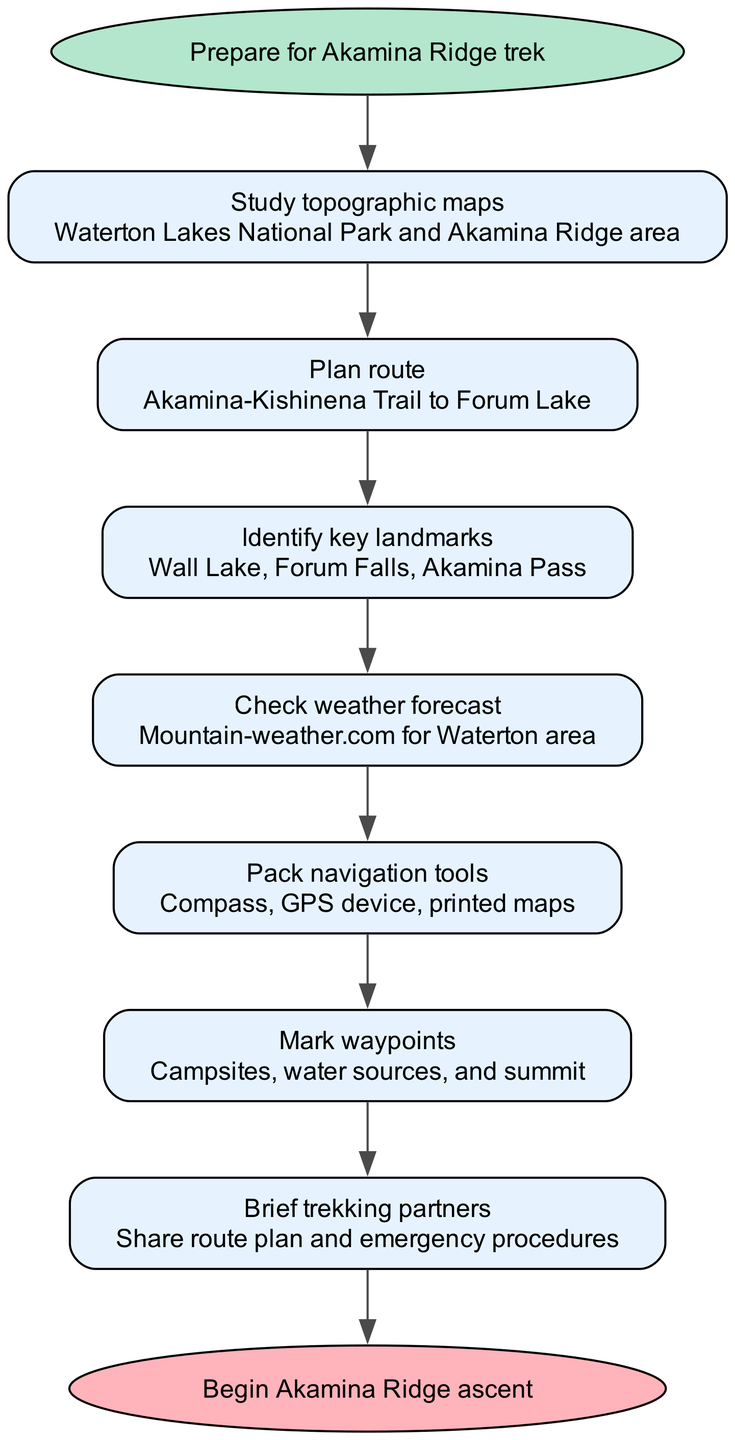What is the first step in the navigation process? The diagram indicates that the first step is "Study topographic maps" which is directly connected to the starting node.
Answer: Study topographic maps How many steps are included in the navigation and route-finding process? By counting each step node connected in the diagram, there are 7 steps outlined before reaching the end node.
Answer: 7 What is the last step before beginning the ascent? The last step listed in the sequence is "Brief trekking partners," which connects to the final node indicating the start of the ascent.
Answer: Brief trekking partners Which step involves checking the weather? The step that specifically mentions checking the weather is "Check weather forecast," which is part of the sequential steps leading to the ascent.
Answer: Check weather forecast What are the key landmarks identified in the process? The landmarks listed in the diagram are "Wall Lake, Forum Falls, Akamina Pass," which are part of the "Identify key landmarks" step.
Answer: Wall Lake, Forum Falls, Akamina Pass What is required to be packed according to the process? The process instructs to "Pack navigation tools" which includes compass, GPS device, and printed maps, detailed in that step.
Answer: Compass, GPS device, printed maps How does one transition from "Plan route" to "Identify key landmarks"? The transition is direct, where "Plan route" leads into "Identify key landmarks" as the next sequential step in the flow.
Answer: Direct transition What are the waypoints that need to be marked? The waypoints to be marked consist of "Campsites, water sources, and summit," as mentioned in the step titled "Mark waypoints."
Answer: Campsites, water sources, summit 